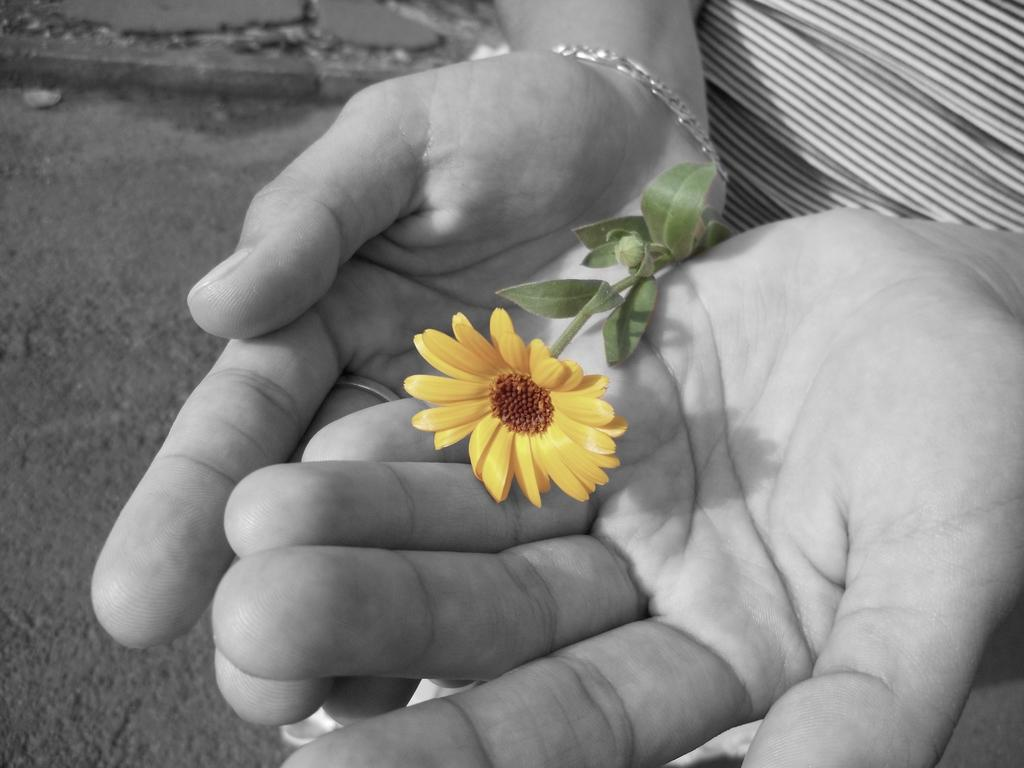What type of flower is in the image? There is a yellow color flower in the image. Who is holding the flower in the image? The flower is being held by a human. What is the color scheme of the image? The image is black and white. Where is the basket located in the image? There is no basket present in the image. Can you describe the snake in the image? There is no snake present in the image. 